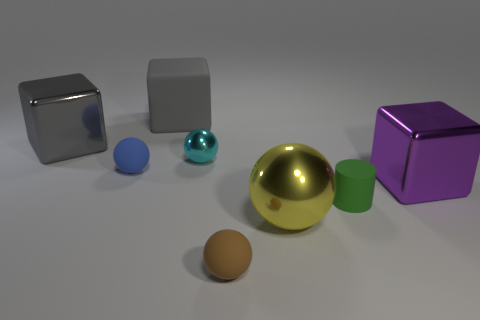What is the shape of the cyan thing?
Offer a very short reply. Sphere. What number of other matte things are the same shape as the small brown rubber thing?
Provide a short and direct response. 1. Is the number of small green cylinders behind the gray metal block less than the number of blue matte spheres in front of the purple cube?
Give a very brief answer. No. There is a large gray shiny cube that is left of the small green rubber thing; what number of yellow metallic objects are behind it?
Make the answer very short. 0. Is there a big purple metallic thing?
Give a very brief answer. Yes. Is there a small blue cylinder made of the same material as the yellow object?
Keep it short and to the point. No. Are there more large yellow things right of the big purple shiny block than cyan things that are in front of the big sphere?
Give a very brief answer. No. Does the blue rubber thing have the same size as the cyan ball?
Provide a succinct answer. Yes. The shiny sphere in front of the metal ball that is behind the big yellow sphere is what color?
Give a very brief answer. Yellow. What is the color of the large ball?
Give a very brief answer. Yellow. 